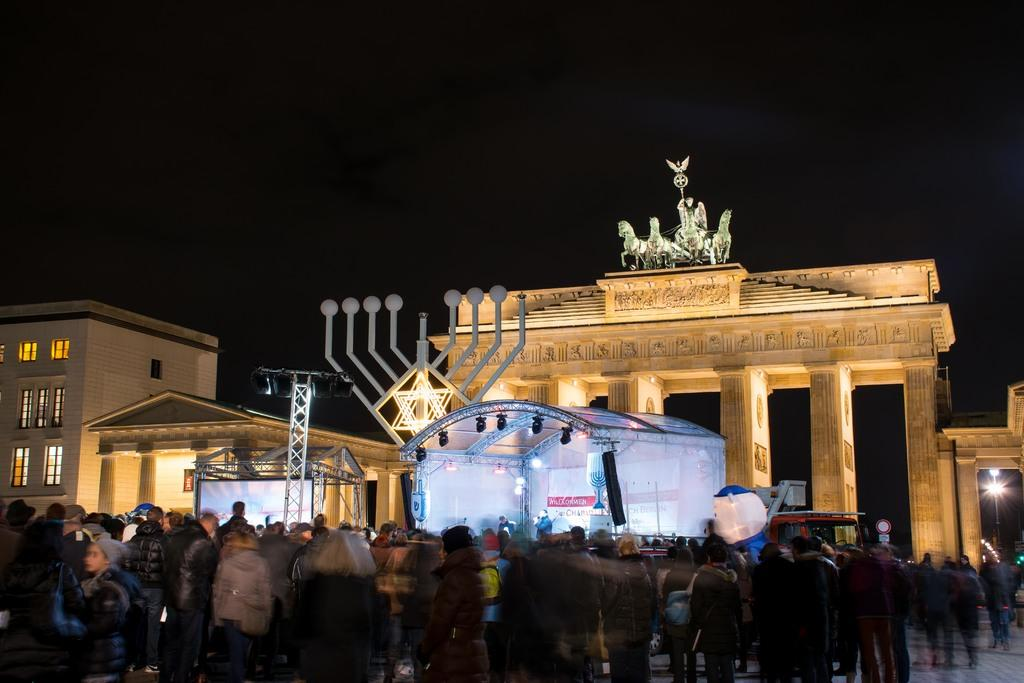How many people can be seen in the image? There are people in the image, but the exact number is not specified. What architectural features are present in the image? There are pillars, statues, poles, and a building in the image. What type of temporary shelter is visible in the image? There is a tent in the image. What lighting elements are present in the image? There are lights in the image. What type of display device is present in the image? There is a screen in the image. What structural elements can be seen in the image? There are borders in the image. What type of openings are present in the building? There are windows in the image. How would you describe the overall lighting condition in the image? The background of the image is dark. How many gallons of oil are being used by the cattle in the image? There are no cattle or oil present in the image. What type of loss is being experienced by the people in the image? There is no indication of any loss being experienced by the people in the image. 